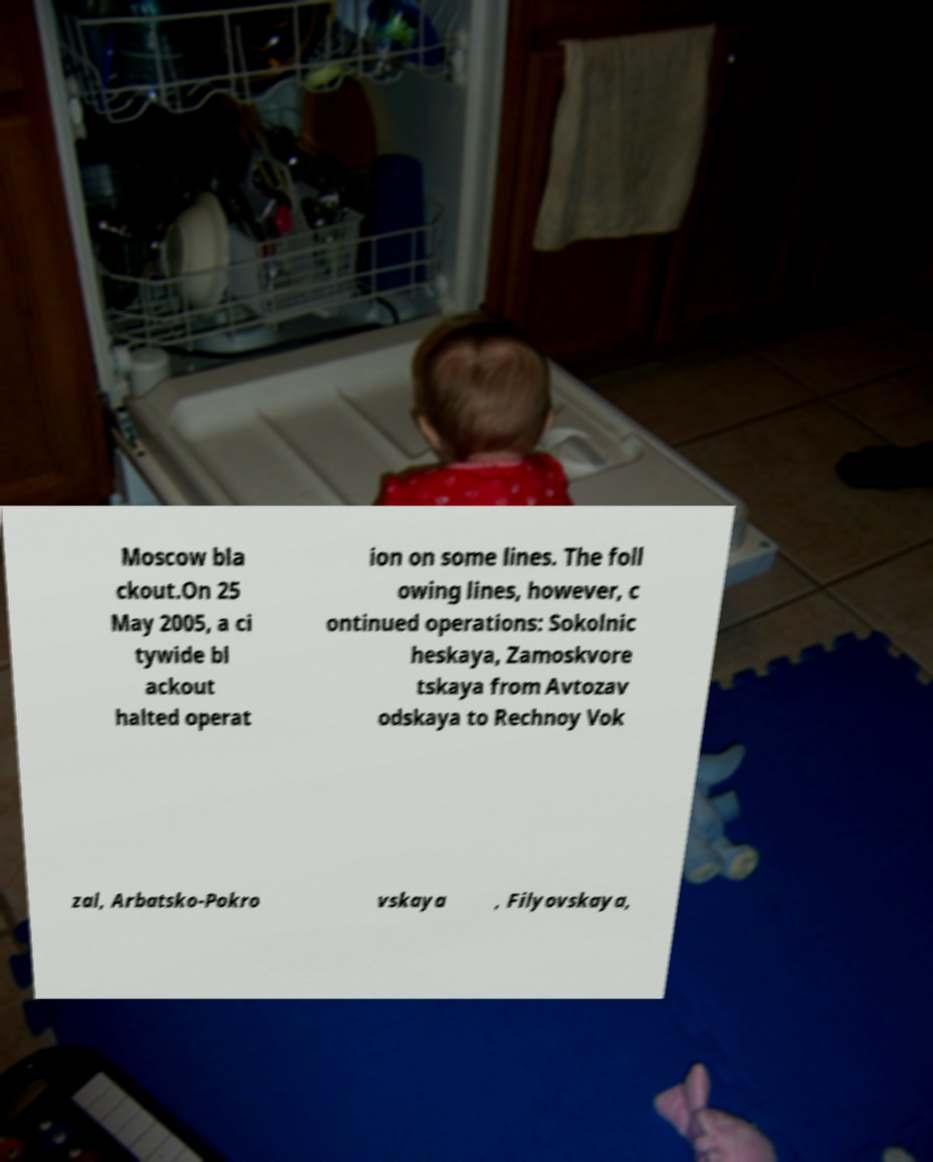I need the written content from this picture converted into text. Can you do that? Moscow bla ckout.On 25 May 2005, a ci tywide bl ackout halted operat ion on some lines. The foll owing lines, however, c ontinued operations: Sokolnic heskaya, Zamoskvore tskaya from Avtozav odskaya to Rechnoy Vok zal, Arbatsko-Pokro vskaya , Filyovskaya, 